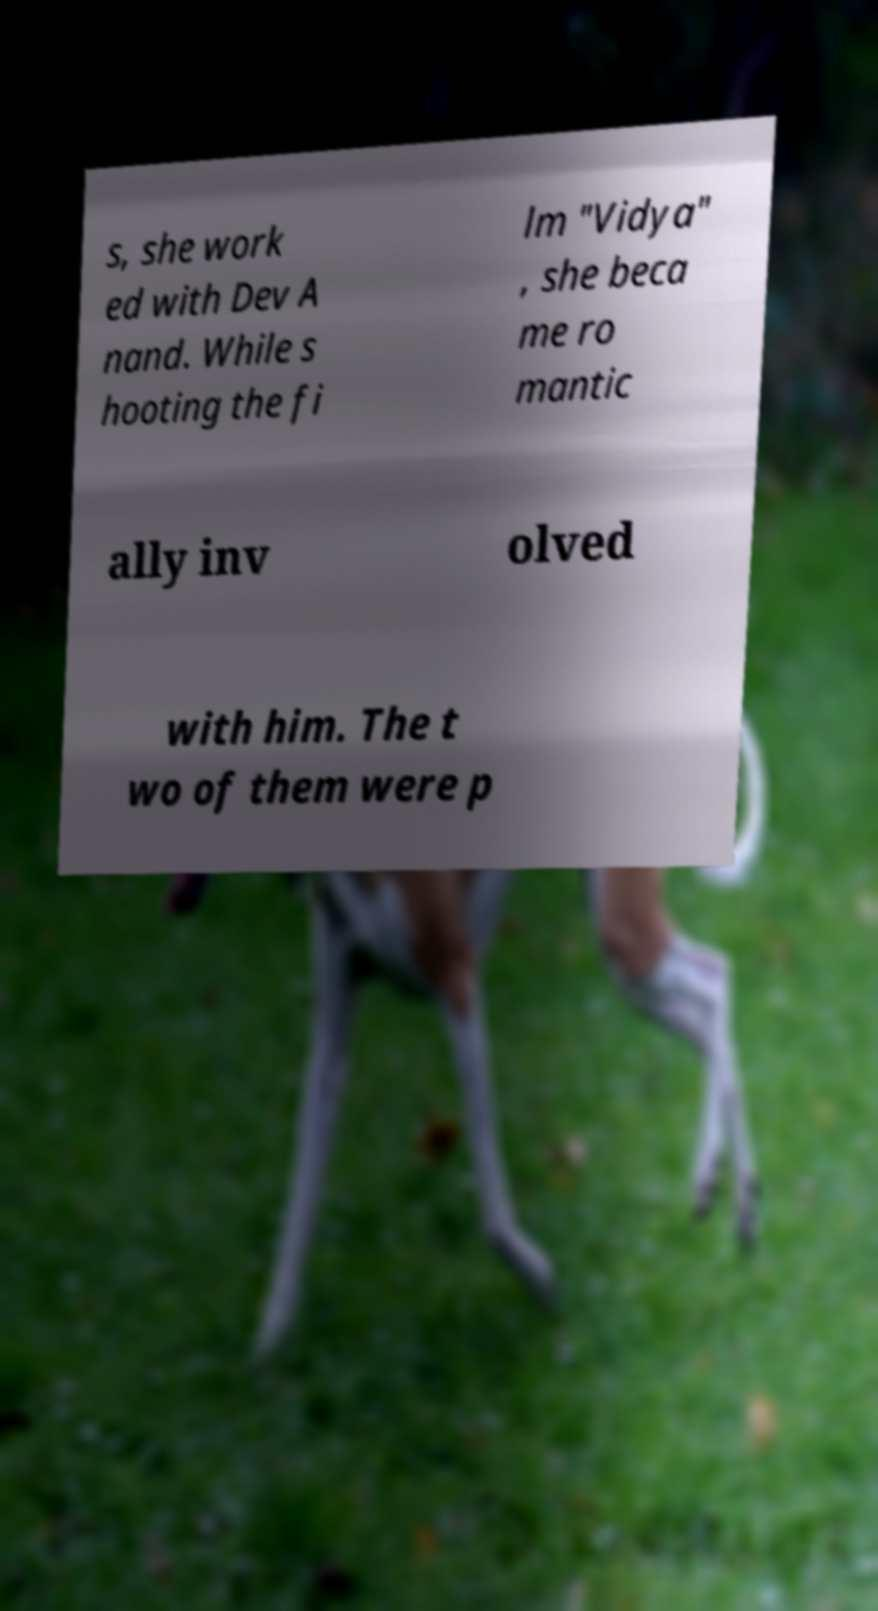I need the written content from this picture converted into text. Can you do that? s, she work ed with Dev A nand. While s hooting the fi lm "Vidya" , she beca me ro mantic ally inv olved with him. The t wo of them were p 